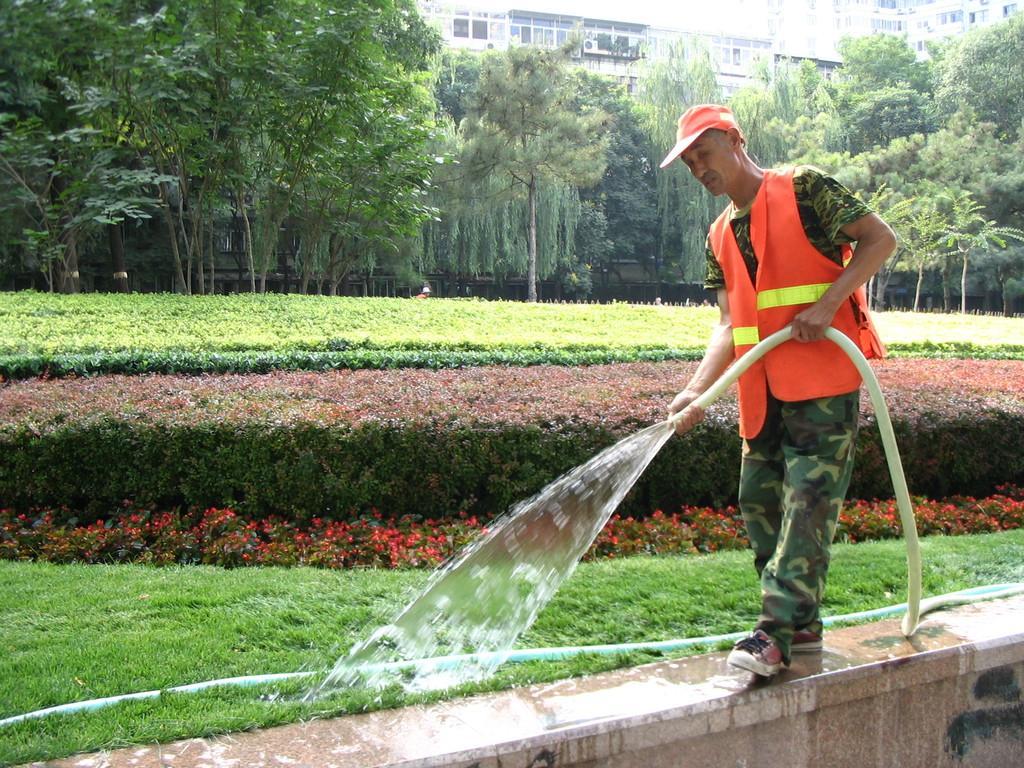Can you describe this image briefly? In the image there is a man in camouflage dress and safety suit spraying water on the grass with a pipe, he is standing on the wall and behind there are many plants and trees all over the place and behind it there are buildings. 